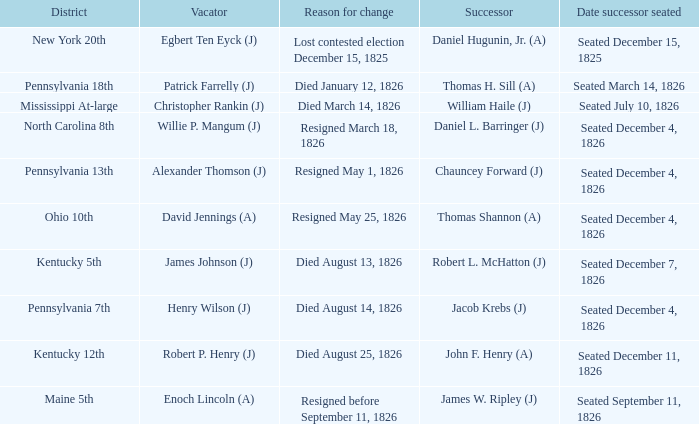Name the vacator who expired on august 13, 182 James Johnson (J). 